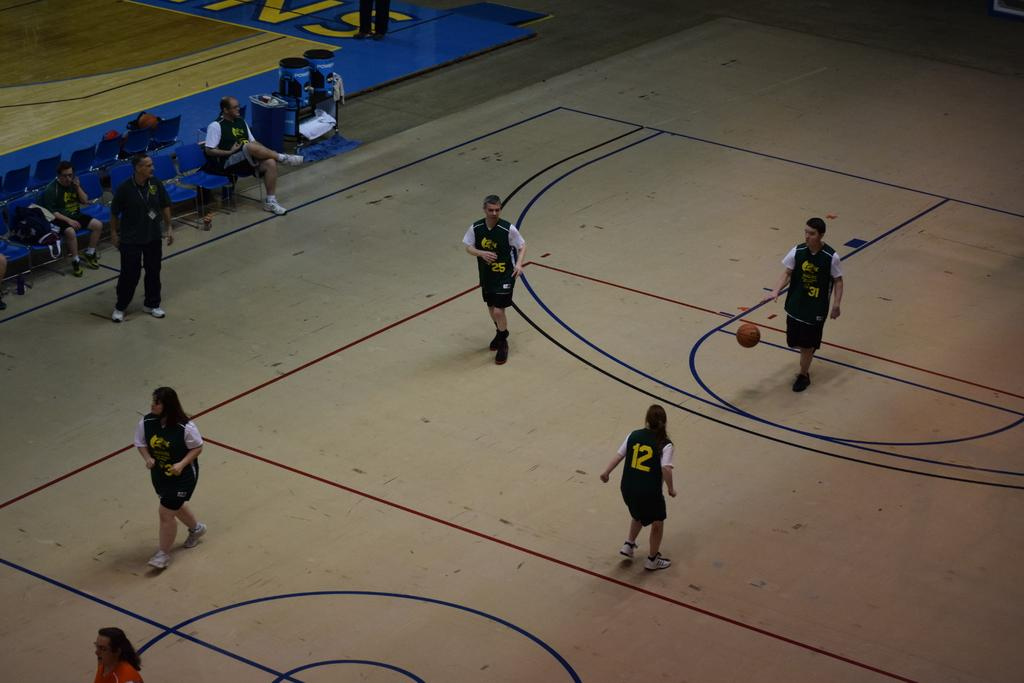<image>
Write a terse but informative summary of the picture. the number 12 is on the back of the player's jersey 